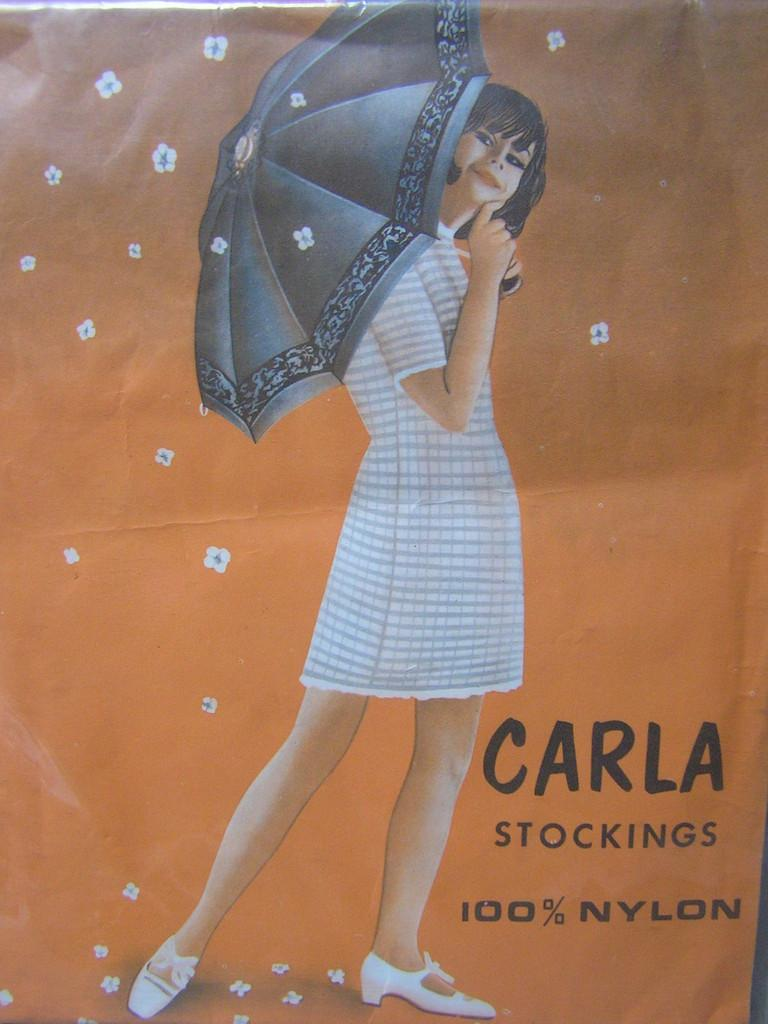What type of artwork is depicted in the image? The image is a painting. Can you describe the main subject of the painting? There is a girl in the center of the painting. What is the girl holding in the painting? The girl is holding an umbrella. Where can we find any text in the painting? There is text in the bottom right corner of the painting. What color is the dress the girl is wearing in the painting? There is no mention of a dress in the provided facts, and the girl's clothing is not described. --- Facts: 1. There is a car in the image. 2. The car is red. 3. The car has four wheels. 4. There is a road in the background of the image. 5. The sky is visible in the background of the image. Absurd Topics: bird, cloud, mountain Conversation: What is the main subject of the image? The main subject of the image is a car. Can you describe the car's appearance? The car is red and has four wheels. What can be seen in the background of the image? There is a road and the sky visible in the background of the image. Reasoning: Let's think step by step in order to produce the conversation. We start by identifying the main subject of the image, which is the car. Then, we describe the car's appearance, focusing on its color and the number of wheels. Finally, we mention the presence of a road and the sky in the background of the image. Absurd Question/Answer: How many birds are flying in the sky in the image? There is no mention of birds in the provided facts, and no birds are visible in the image. --- Facts: 1. There is a group of people in the image. 2. The people are wearing hats. 3. The people are holding hands. 4. There is a river in the background of the image. 5. The sky is visible in the background of the image. Absurd Topics: fish, boat, bridge Conversation: What is the main subject of the image? The main subject of the image is a group of people. Can you describe the people's appearance? The people are wearing hats and holding hands. What can be seen in the background of the image? There is a river and the sky visible in the background of the image. Reasoning: Let's think step by step in order to produce the conversation. We start by identifying the main subject of the image, which is the group of people. Then, we describe the people's appearance, focusing on their hats and the fact that they are holding hands. Finally, we mention the presence of a river and the sky in the background of the image. Absurd Question/Answer: 